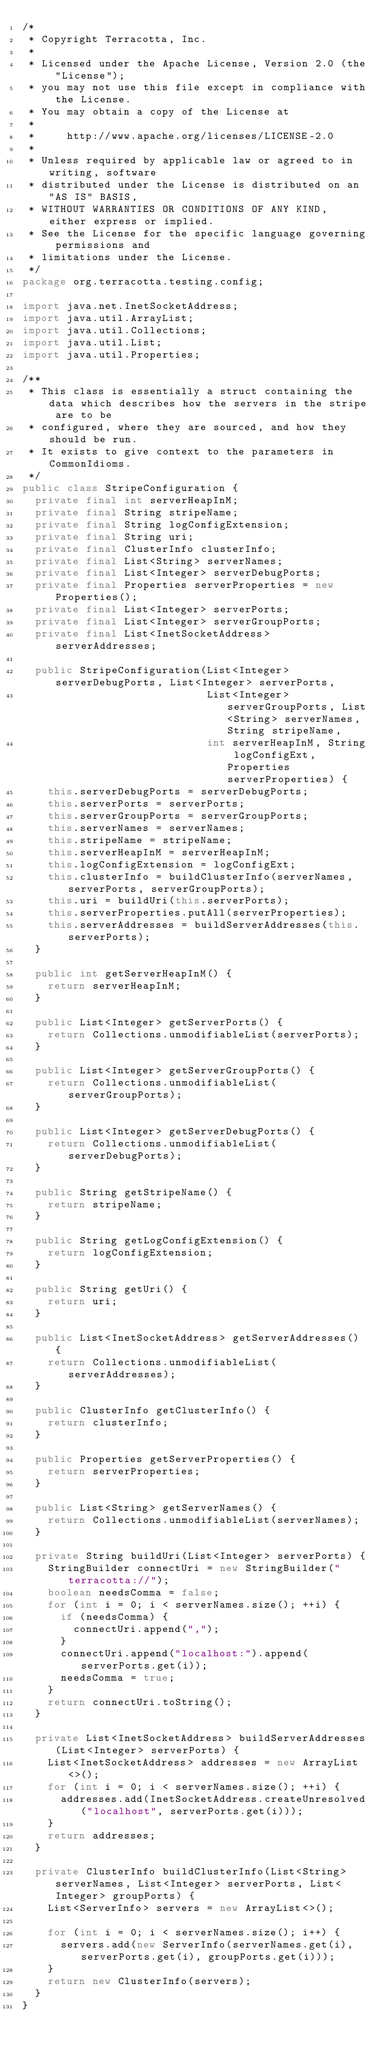<code> <loc_0><loc_0><loc_500><loc_500><_Java_>/*
 * Copyright Terracotta, Inc.
 *
 * Licensed under the Apache License, Version 2.0 (the "License");
 * you may not use this file except in compliance with the License.
 * You may obtain a copy of the License at
 *
 *     http://www.apache.org/licenses/LICENSE-2.0
 *
 * Unless required by applicable law or agreed to in writing, software
 * distributed under the License is distributed on an "AS IS" BASIS,
 * WITHOUT WARRANTIES OR CONDITIONS OF ANY KIND, either express or implied.
 * See the License for the specific language governing permissions and
 * limitations under the License.
 */
package org.terracotta.testing.config;

import java.net.InetSocketAddress;
import java.util.ArrayList;
import java.util.Collections;
import java.util.List;
import java.util.Properties;

/**
 * This class is essentially a struct containing the data which describes how the servers in the stripe are to be
 * configured, where they are sourced, and how they should be run.
 * It exists to give context to the parameters in CommonIdioms.
 */
public class StripeConfiguration {
  private final int serverHeapInM;
  private final String stripeName;
  private final String logConfigExtension;
  private final String uri;
  private final ClusterInfo clusterInfo;
  private final List<String> serverNames;
  private final List<Integer> serverDebugPorts;
  private final Properties serverProperties = new Properties();
  private final List<Integer> serverPorts;
  private final List<Integer> serverGroupPorts;
  private final List<InetSocketAddress> serverAddresses;

  public StripeConfiguration(List<Integer> serverDebugPorts, List<Integer> serverPorts,
                             List<Integer> serverGroupPorts, List<String> serverNames, String stripeName,
                             int serverHeapInM, String logConfigExt, Properties serverProperties) {
    this.serverDebugPorts = serverDebugPorts;
    this.serverPorts = serverPorts;
    this.serverGroupPorts = serverGroupPorts;
    this.serverNames = serverNames;
    this.stripeName = stripeName;
    this.serverHeapInM = serverHeapInM;
    this.logConfigExtension = logConfigExt;
    this.clusterInfo = buildClusterInfo(serverNames, serverPorts, serverGroupPorts);
    this.uri = buildUri(this.serverPorts);
    this.serverProperties.putAll(serverProperties);
    this.serverAddresses = buildServerAddresses(this.serverPorts);
  }
  
  public int getServerHeapInM() {
    return serverHeapInM;
  }

  public List<Integer> getServerPorts() {
    return Collections.unmodifiableList(serverPorts);
  }

  public List<Integer> getServerGroupPorts() {
    return Collections.unmodifiableList(serverGroupPorts);
  }

  public List<Integer> getServerDebugPorts() {
    return Collections.unmodifiableList(serverDebugPorts);
  }

  public String getStripeName() {
    return stripeName;
  }

  public String getLogConfigExtension() {
    return logConfigExtension;
  }

  public String getUri() {
    return uri;
  }

  public List<InetSocketAddress> getServerAddresses() {
    return Collections.unmodifiableList(serverAddresses);
  }

  public ClusterInfo getClusterInfo() {
    return clusterInfo;
  }

  public Properties getServerProperties() {
    return serverProperties;
  }

  public List<String> getServerNames() {
    return Collections.unmodifiableList(serverNames);
  }

  private String buildUri(List<Integer> serverPorts) {
    StringBuilder connectUri = new StringBuilder("terracotta://");
    boolean needsComma = false;
    for (int i = 0; i < serverNames.size(); ++i) {
      if (needsComma) {
        connectUri.append(",");
      }
      connectUri.append("localhost:").append(serverPorts.get(i));
      needsComma = true;
    }
    return connectUri.toString();
  }

  private List<InetSocketAddress> buildServerAddresses(List<Integer> serverPorts) {
    List<InetSocketAddress> addresses = new ArrayList<>();
    for (int i = 0; i < serverNames.size(); ++i) {
      addresses.add(InetSocketAddress.createUnresolved("localhost", serverPorts.get(i)));
    }
    return addresses;
  }

  private ClusterInfo buildClusterInfo(List<String> serverNames, List<Integer> serverPorts, List<Integer> groupPorts) {
    List<ServerInfo> servers = new ArrayList<>();

    for (int i = 0; i < serverNames.size(); i++) {
      servers.add(new ServerInfo(serverNames.get(i), serverPorts.get(i), groupPorts.get(i)));
    }
    return new ClusterInfo(servers);
  }
}
</code> 